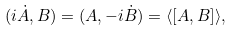<formula> <loc_0><loc_0><loc_500><loc_500>( i \dot { A } , B ) = ( A , - i \dot { B } ) = \langle [ A , B ] \rangle ,</formula> 